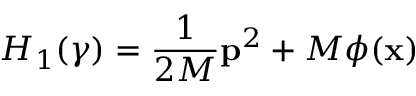Convert formula to latex. <formula><loc_0><loc_0><loc_500><loc_500>H _ { 1 } ( \gamma ) = \frac { 1 } { 2 M } p ^ { 2 } + M \phi ( x )</formula> 